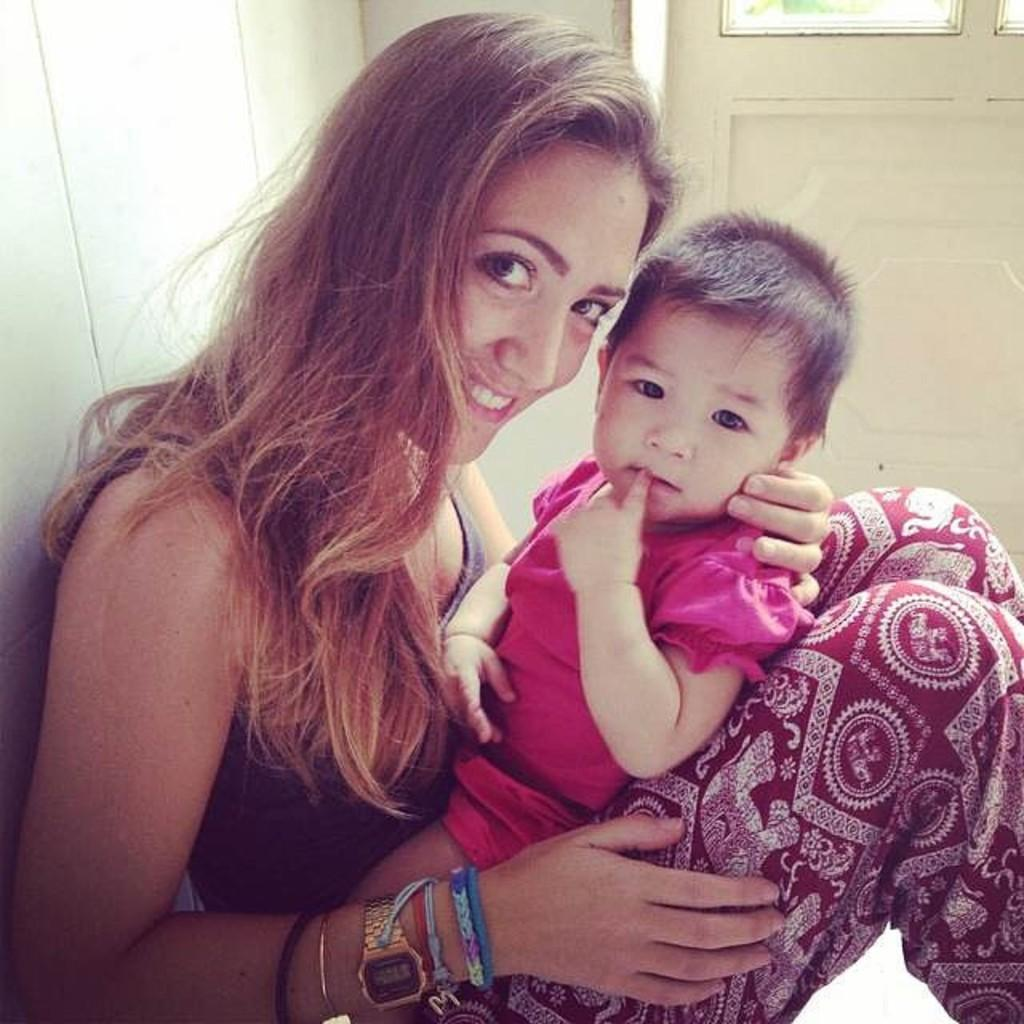How many people are present in the image? There are two people in the image. What can be seen in the background of the image? There is a wall in the image. Is there any opening in the wall visible in the image? Yes, there is a window in the image. What type of reward is the kitty receiving in the image? There is no kitty present in the image, so it is not possible to determine what, if any, reward might be given. 